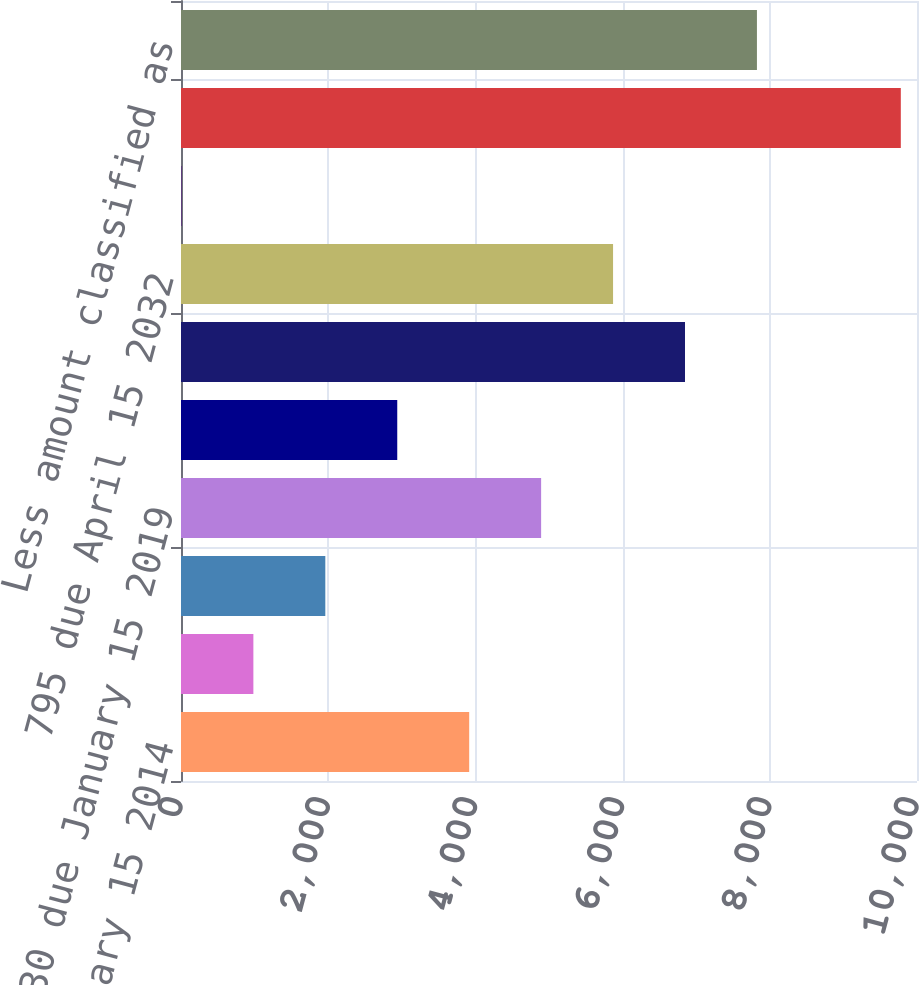Convert chart. <chart><loc_0><loc_0><loc_500><loc_500><bar_chart><fcel>5625 due January 15 2014<fcel>Non-interest bearing<fcel>825 due July 1 2018<fcel>630 due January 15 2019<fcel>750 due September 15 2027<fcel>7875 due September 30 2031<fcel>795 due April 15 2032<fcel>Net discount on other<fcel>Total debt<fcel>Less amount classified as<nl><fcel>3915.6<fcel>983.4<fcel>1960.8<fcel>4893<fcel>2938.2<fcel>6847.8<fcel>5870.4<fcel>6<fcel>9780<fcel>7825.2<nl></chart> 